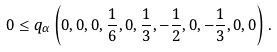<formula> <loc_0><loc_0><loc_500><loc_500>0 \leq q _ { \alpha } \left ( 0 , 0 , 0 , \frac { 1 } { 6 } , 0 , \frac { 1 } { 3 } , - \frac { 1 } { 2 } , 0 , - \frac { 1 } { 3 } , 0 , 0 \right ) .</formula> 